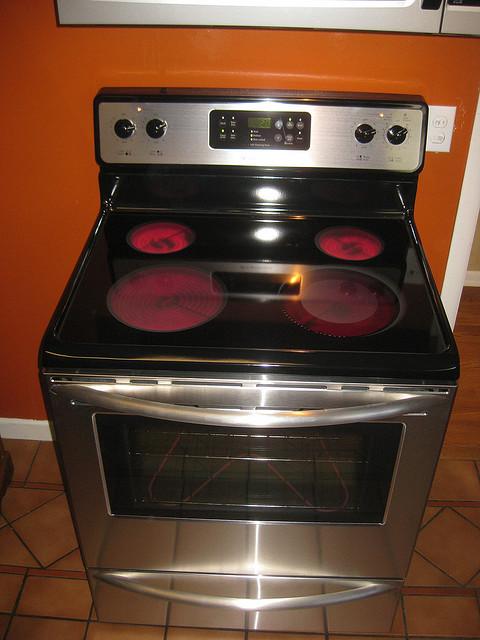Are the burners on this stove on?
Keep it brief. Yes. Is the stove glowing?
Give a very brief answer. Yes. What appliance is this?
Keep it brief. Stove. 